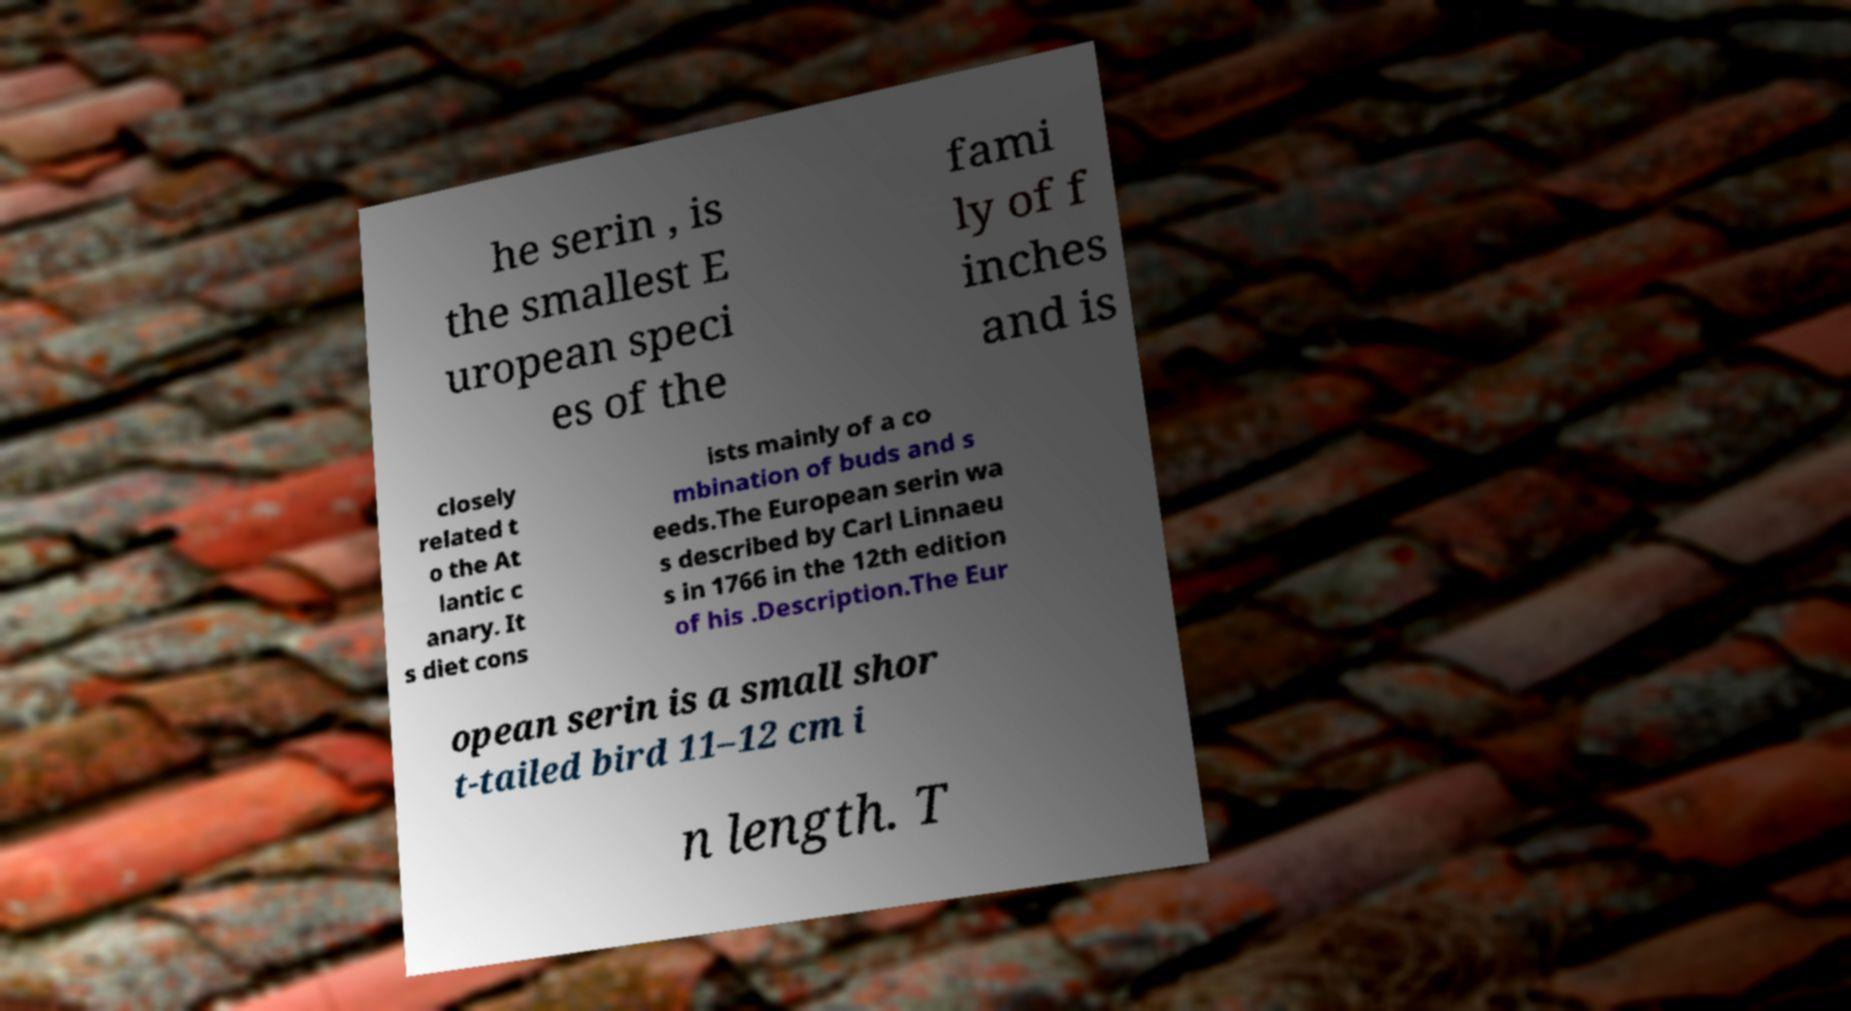For documentation purposes, I need the text within this image transcribed. Could you provide that? he serin , is the smallest E uropean speci es of the fami ly of f inches and is closely related t o the At lantic c anary. It s diet cons ists mainly of a co mbination of buds and s eeds.The European serin wa s described by Carl Linnaeu s in 1766 in the 12th edition of his .Description.The Eur opean serin is a small shor t-tailed bird 11–12 cm i n length. T 